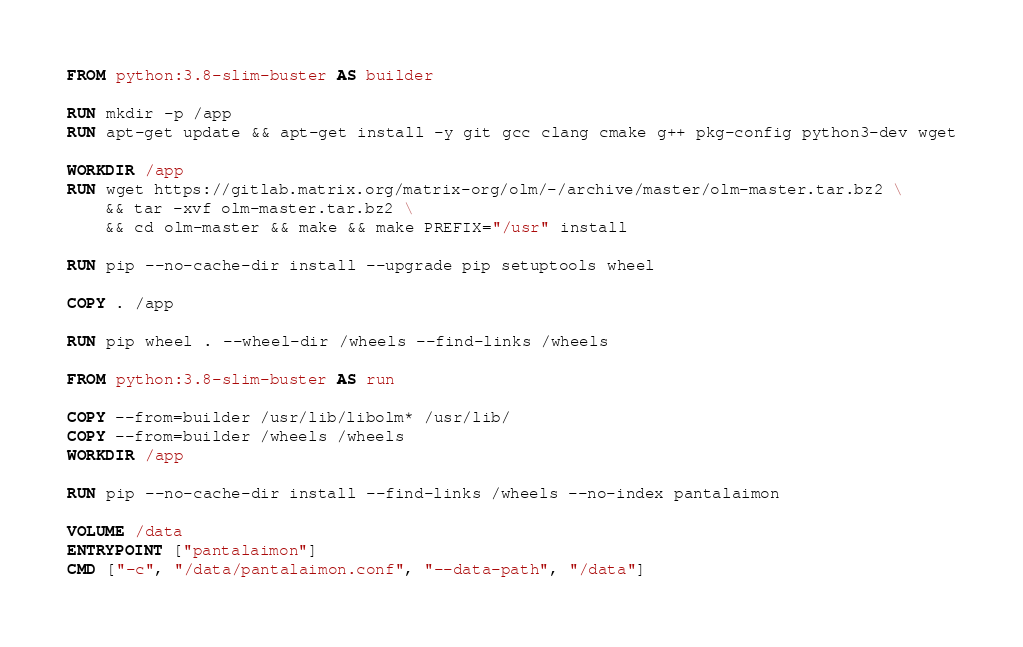<code> <loc_0><loc_0><loc_500><loc_500><_Dockerfile_>FROM python:3.8-slim-buster AS builder

RUN mkdir -p /app
RUN apt-get update && apt-get install -y git gcc clang cmake g++ pkg-config python3-dev wget

WORKDIR /app
RUN wget https://gitlab.matrix.org/matrix-org/olm/-/archive/master/olm-master.tar.bz2 \
    && tar -xvf olm-master.tar.bz2 \
    && cd olm-master && make && make PREFIX="/usr" install

RUN pip --no-cache-dir install --upgrade pip setuptools wheel

COPY . /app

RUN pip wheel . --wheel-dir /wheels --find-links /wheels

FROM python:3.8-slim-buster AS run

COPY --from=builder /usr/lib/libolm* /usr/lib/
COPY --from=builder /wheels /wheels
WORKDIR /app

RUN pip --no-cache-dir install --find-links /wheels --no-index pantalaimon

VOLUME /data
ENTRYPOINT ["pantalaimon"]
CMD ["-c", "/data/pantalaimon.conf", "--data-path", "/data"]
</code> 